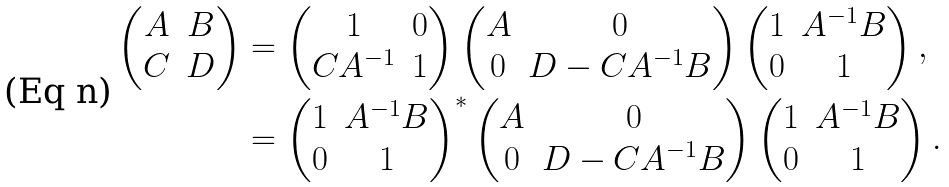<formula> <loc_0><loc_0><loc_500><loc_500>\begin{pmatrix} A & B \\ C & D \end{pmatrix} & = \begin{pmatrix} 1 & 0 \\ C A ^ { - 1 } & 1 \end{pmatrix} \begin{pmatrix} A & 0 \\ 0 & D - C A ^ { - 1 } B \end{pmatrix} \begin{pmatrix} 1 & A ^ { - 1 } B \\ 0 & 1 \end{pmatrix} , \\ & = \begin{pmatrix} 1 & A ^ { - 1 } B \\ 0 & 1 \end{pmatrix} ^ { * } \begin{pmatrix} A & 0 \\ 0 & D - C A ^ { - 1 } B \end{pmatrix} \begin{pmatrix} 1 & A ^ { - 1 } B \\ 0 & 1 \end{pmatrix} .</formula> 